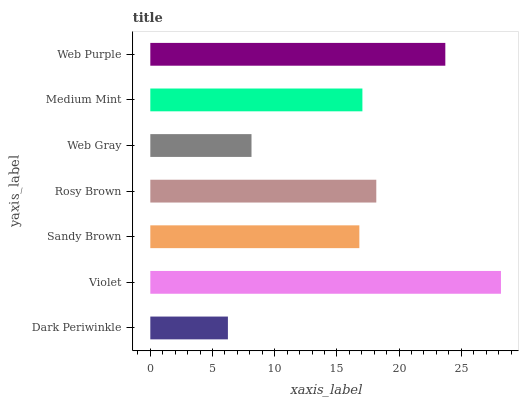Is Dark Periwinkle the minimum?
Answer yes or no. Yes. Is Violet the maximum?
Answer yes or no. Yes. Is Sandy Brown the minimum?
Answer yes or no. No. Is Sandy Brown the maximum?
Answer yes or no. No. Is Violet greater than Sandy Brown?
Answer yes or no. Yes. Is Sandy Brown less than Violet?
Answer yes or no. Yes. Is Sandy Brown greater than Violet?
Answer yes or no. No. Is Violet less than Sandy Brown?
Answer yes or no. No. Is Medium Mint the high median?
Answer yes or no. Yes. Is Medium Mint the low median?
Answer yes or no. Yes. Is Rosy Brown the high median?
Answer yes or no. No. Is Sandy Brown the low median?
Answer yes or no. No. 